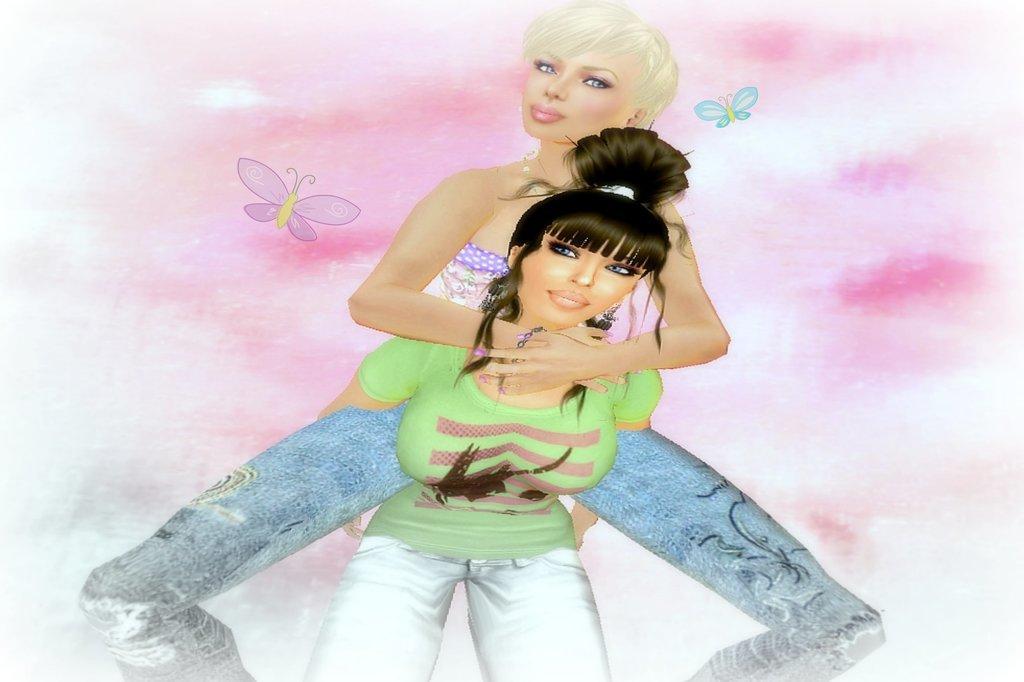Could you give a brief overview of what you see in this image? In this image I can see the digital art. I can see two people with different color dresses. And I can see the white and pink color background and there are some butterflies can be seen. 